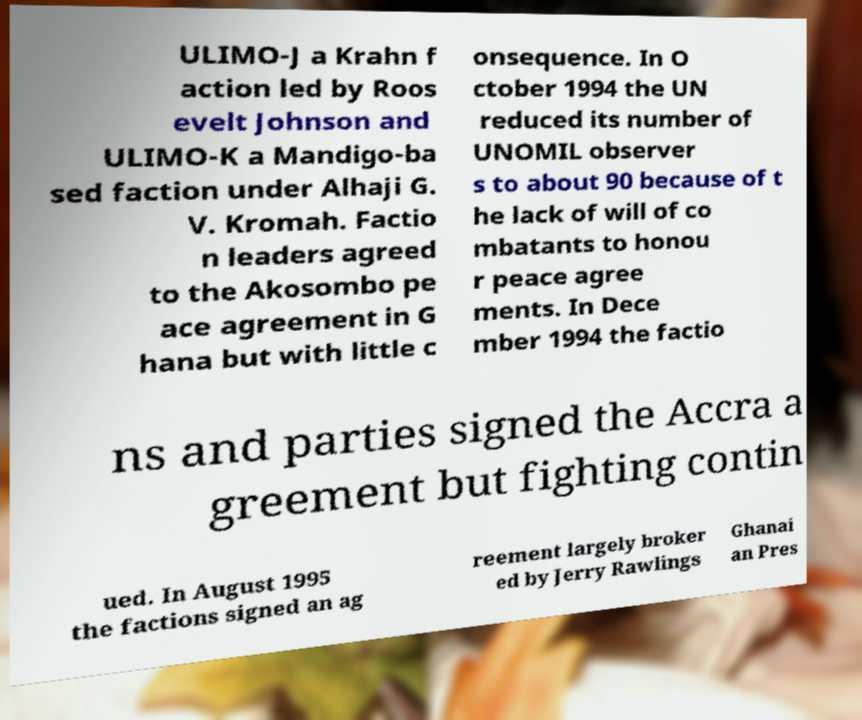Can you read and provide the text displayed in the image?This photo seems to have some interesting text. Can you extract and type it out for me? ULIMO-J a Krahn f action led by Roos evelt Johnson and ULIMO-K a Mandigo-ba sed faction under Alhaji G. V. Kromah. Factio n leaders agreed to the Akosombo pe ace agreement in G hana but with little c onsequence. In O ctober 1994 the UN reduced its number of UNOMIL observer s to about 90 because of t he lack of will of co mbatants to honou r peace agree ments. In Dece mber 1994 the factio ns and parties signed the Accra a greement but fighting contin ued. In August 1995 the factions signed an ag reement largely broker ed by Jerry Rawlings Ghanai an Pres 